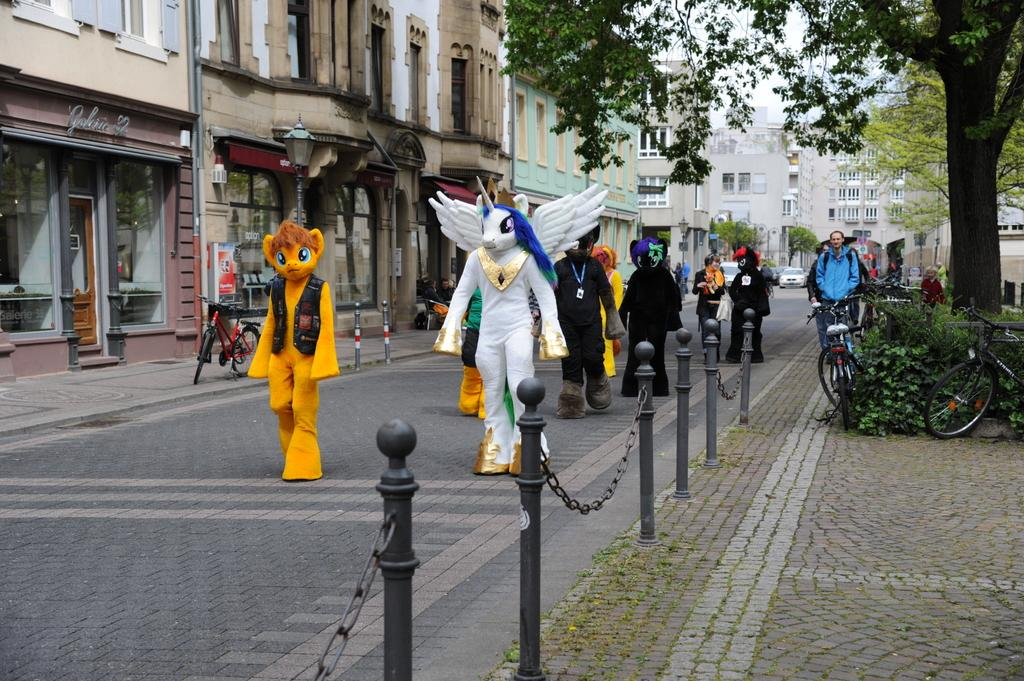Who or what can be seen in the image? There are people in the image. What are the people wearing? The people are wearing different costumes. What are the people doing in the image? The people are walking on the road. What can be seen in the background of the image? There are buildings and trees visible in the image. What type of machine can be seen in the wilderness in the image? There is no machine or wilderness present in the image. How often do the people wash their costumes in the image? There is no information about the people washing their costumes in the image. 